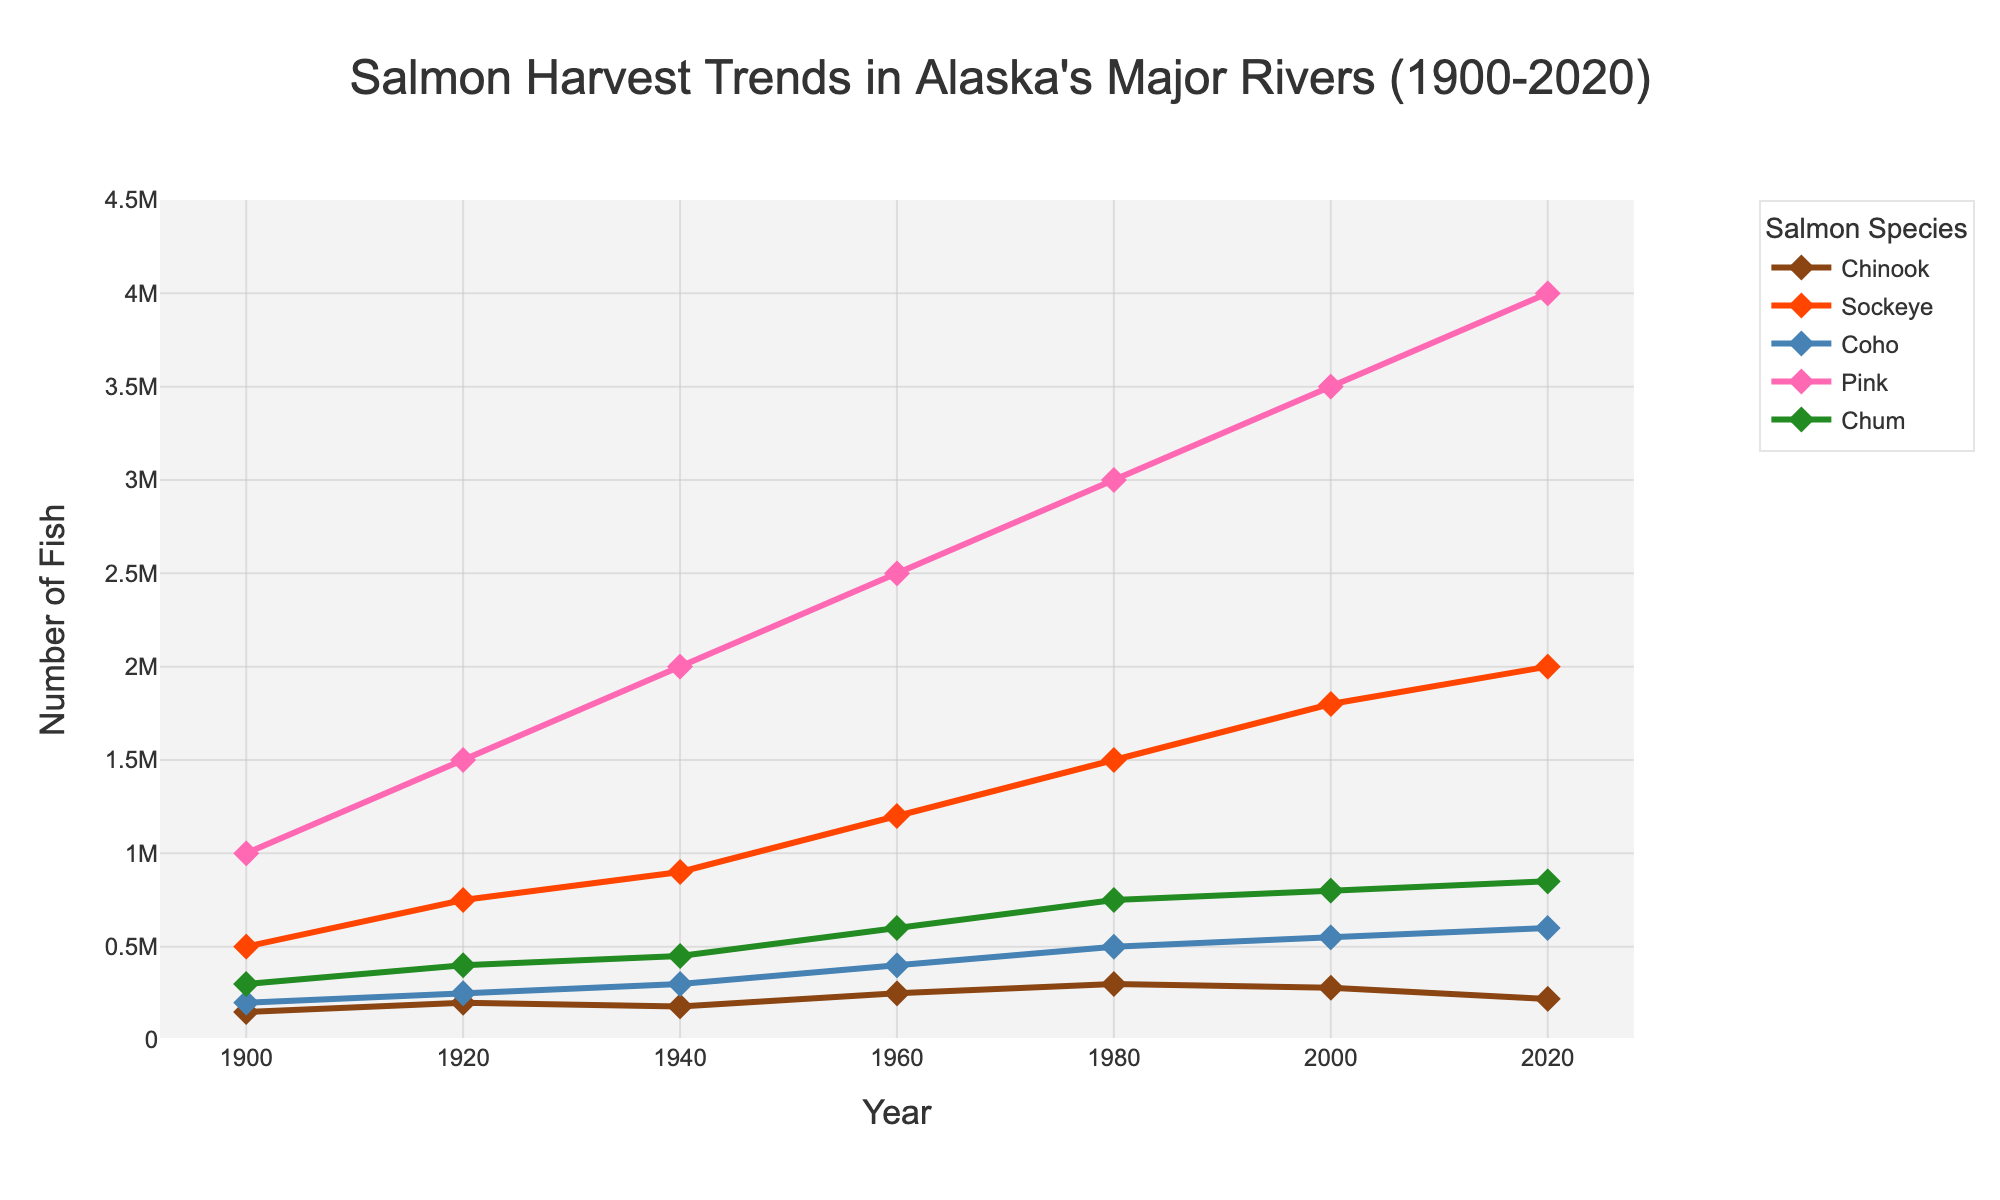What species of salmon had the highest annual harvest in 2020? By referring to the figure's markers and colors, recognize which species had the peak value in 2020. The pink salmon, marked with a specific line and marker, reached a value near 4,000,000 in 2020
Answer: Pink Salmon Between 1960 and 1980, which species saw the largest increase in harvest numbers? Analyze the figure to locate the harvest values for all species in 1960 and 1980. Determine the differences for each species between these years, focusing on the highest increase.
Answer: Pink Salmon Looking at the entire time span, which species demonstrated a steady increase without any notable decrease? Scan all the species lines from 1900 to 2020 and identify which species showed a consistent upward trend. Sockeye salmon demonstrates this pattern.
Answer: Sockeye Salmon What is the combined harvest number of all salmon species in 1940? Identify the harvest values for each species in 1940, then sum these values: Chinook (180,000) + Sockeye (900,000) + Coho (300,000) + Pink (2,000,000) + Chum (450,000) = 3,830,000.
Answer: 3,830,000 Which species had the smallest harvest number in 1920 compared to others? Evaluate and compare the heights of the markers and lines in 1920 for all species and identify the species with the lowest harvest number. Chinook had the smallest value of 200,000.
Answer: Chinook Which salmon species showed the largest drop in harvest from 2000 to 2020? Compare the 2000 and 2020 values for all species. The Chinook salmon had a decrease from 280,000 to 220,000, which is a drop of 60,000.
Answer: Chinook Salmon What was the difference in the Chum salmon harvest from 1960 to 2000? Identify the harvest values for Chum salmon in both 1960 and 2000 by looking at the chart. The difference is 800,000 - 600,000 = 200,000.
Answer: 200,000 Which two species had their harvest numbers cross paths (i.e., equal values) around any given year? Look for any points where two different species have the same harvest level around the same year. Sockeye and Pink salmon had similar values around 1960.
Answer: Sockeye and Pink If you average the annual harvest of Coho salmon from 1900 to 2020, what is the value? Identify the values for Coho salmon in each given year, then sum and divide by the number of years (7 points): (200,000 + 250,000 + 300,000 + 400,000 + 500,000 + 550,000 + 600,000) / 7 = 400,000.
Answer: 400,000 